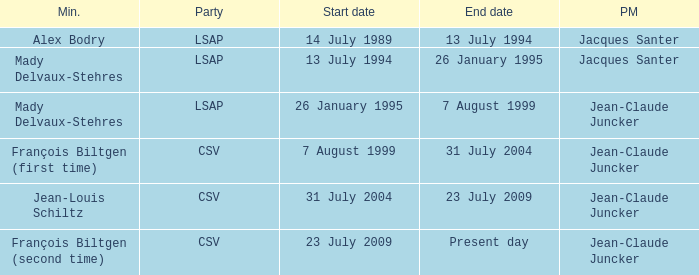What was the end date when Alex Bodry was the minister? 13 July 1994. 